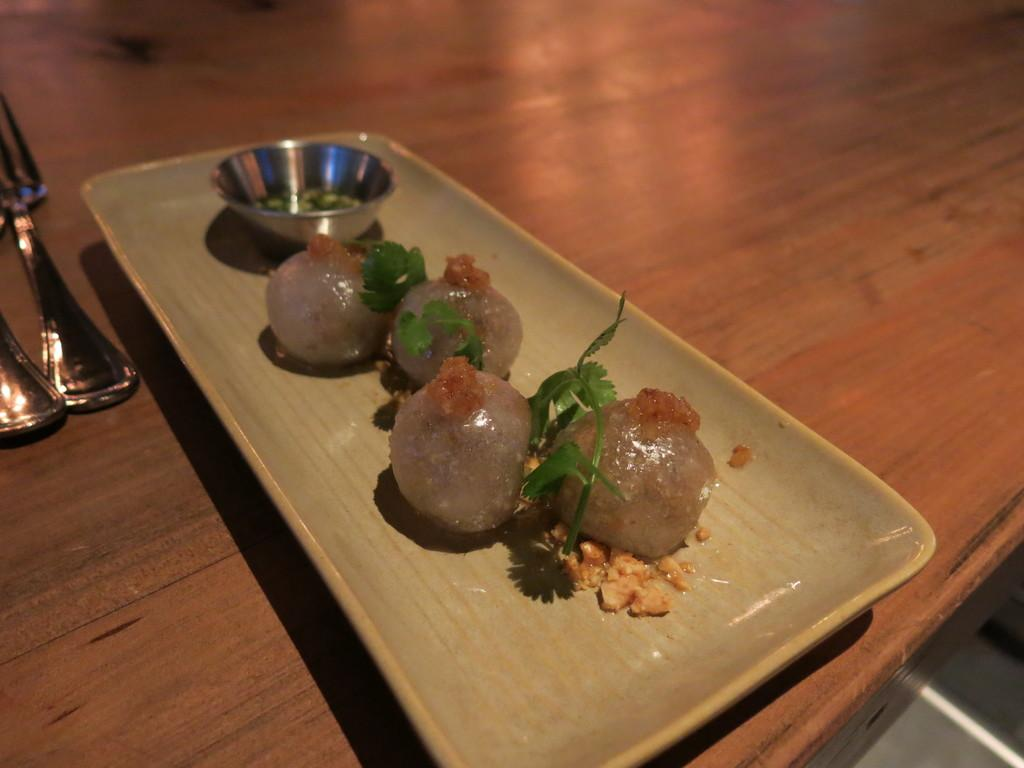What is on the plate in the image? There are food items on a plate in the image. What utensil is located near the plate? There is a fork on the left side of the plate in the image. What type of ring can be seen on the church in the image? There is no church or ring present in the image; it only features a plate with food items and a fork. 